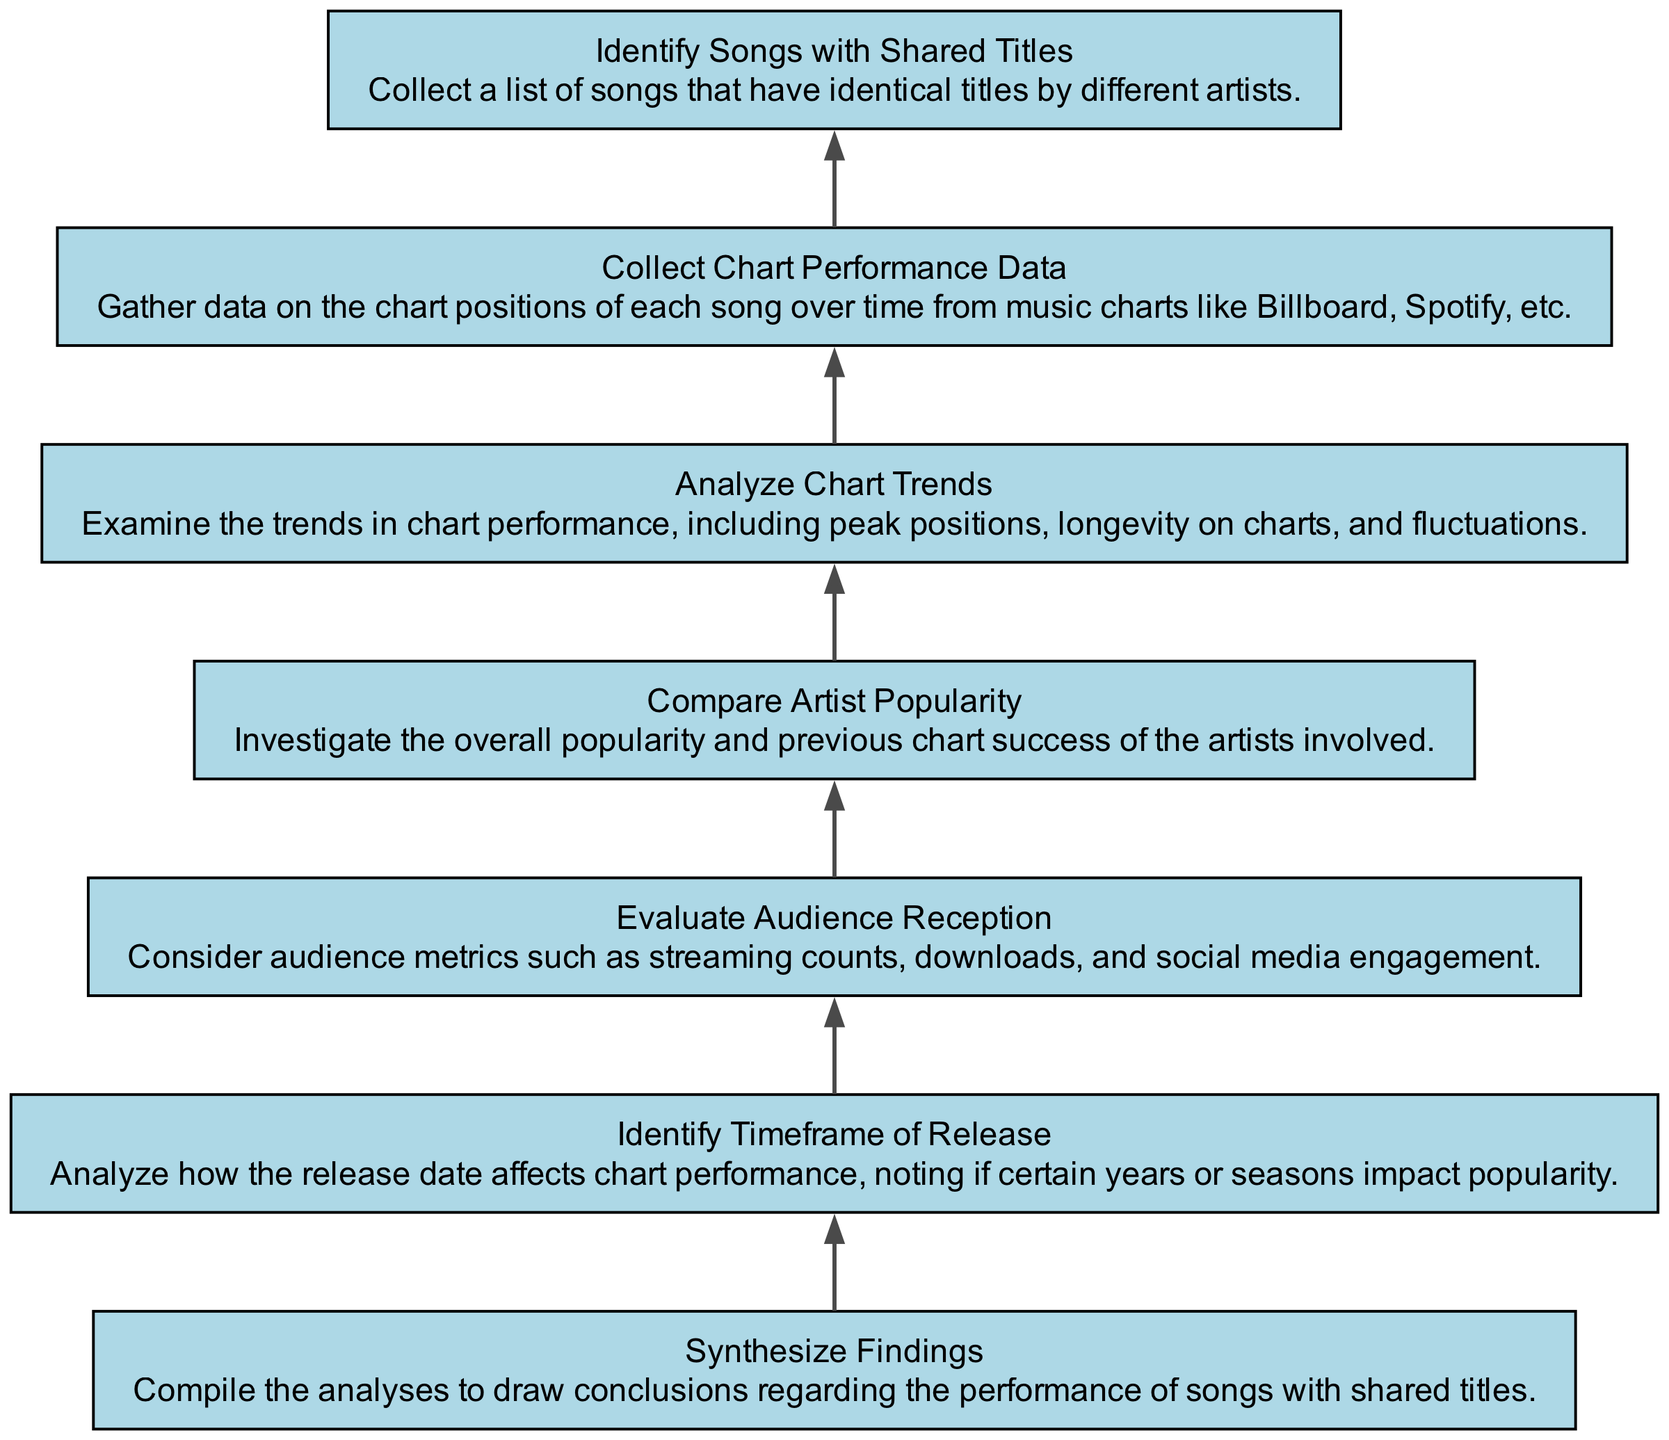What is the first step in the flow chart? The first step in the flow chart is to "Identify Songs with Shared Titles," which is the first node listed in the diagram.
Answer: Identify Songs with Shared Titles How many elements are in the diagram? The diagram contains a total of seven elements, as indicated by the seven nodes listed.
Answer: 7 Which two steps are directly connected? Each step in the diagram is connected to the step that follows it; for example, "Analyze Chart Trends" is directly connected to "Collect Chart Performance Data."
Answer: Analyze Chart Trends and Collect Chart Performance Data What is the last step in this flow chart? The final step in the flow chart is "Synthesize Findings," which compiles all analyses.
Answer: Synthesize Findings Which node describes the investigation of artist popularity? The node that describes the investigation of artist popularity is "Compare Artist Popularity," detailing the analysis of artists’ overall popularity.
Answer: Compare Artist Popularity What do you examine in "Analyze Chart Trends"? In "Analyze Chart Trends," one examines trends in chart performance, including peak positions and fluctuations.
Answer: Trends in chart performance, peak positions, and fluctuations How does the release date affect the analysis? The "Identify Timeframe of Release" node specifically analyzes how the release date influences chart performance and popularity.
Answer: Chart performance and popularity What conclusion is drawn from the final node? The final node recommends compiling all collected information to draw conclusions regarding the performance of songs sharing the same titles.
Answer: Compile information to draw conclusions 